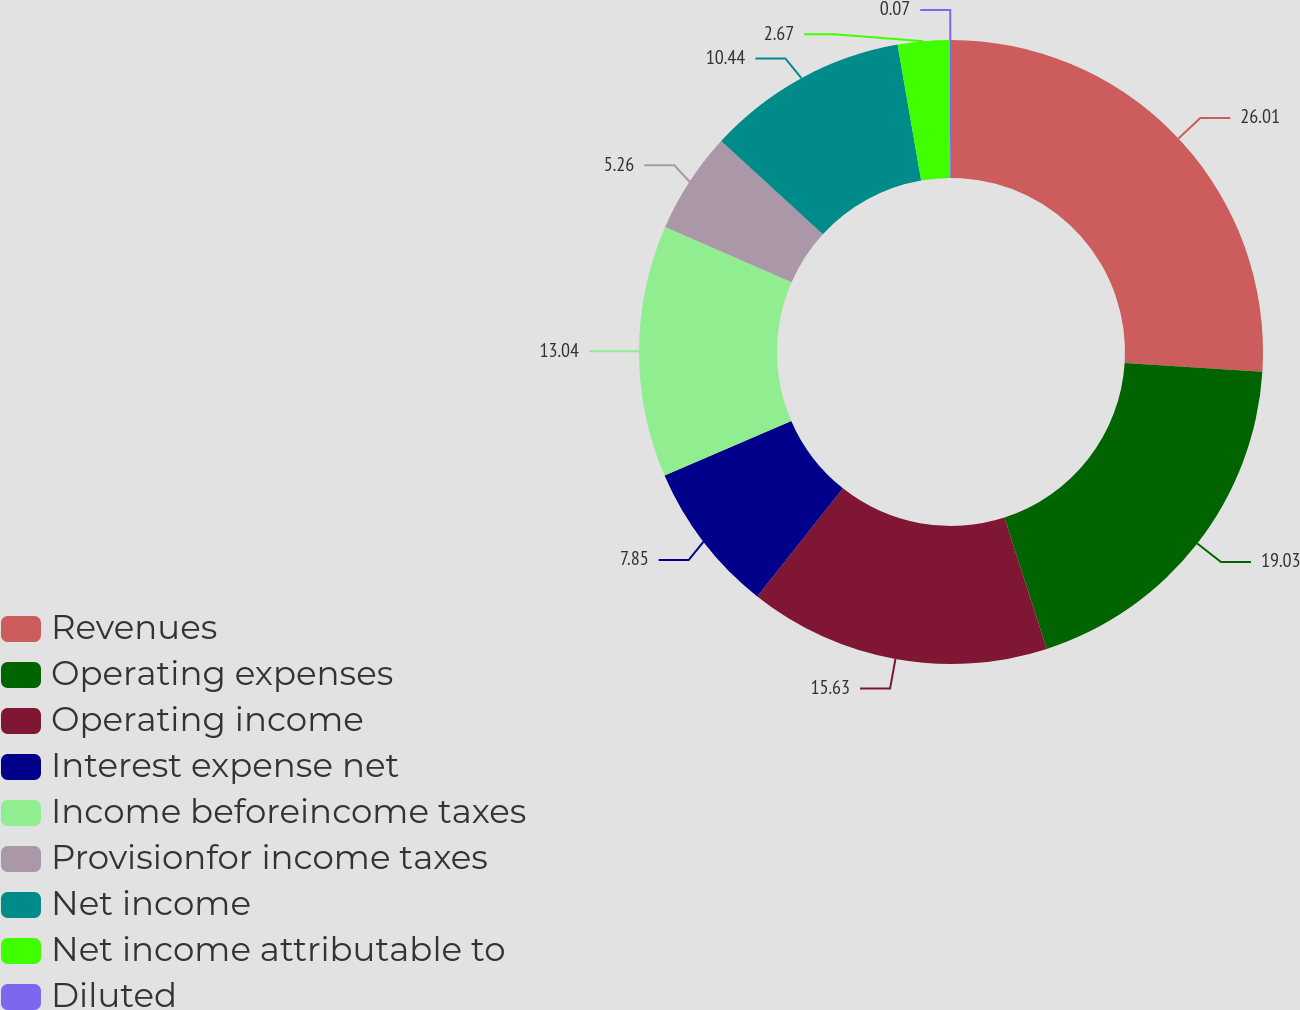Convert chart to OTSL. <chart><loc_0><loc_0><loc_500><loc_500><pie_chart><fcel>Revenues<fcel>Operating expenses<fcel>Operating income<fcel>Interest expense net<fcel>Income beforeincome taxes<fcel>Provisionfor income taxes<fcel>Net income<fcel>Net income attributable to<fcel>Diluted<nl><fcel>26.0%<fcel>19.03%<fcel>15.63%<fcel>7.85%<fcel>13.04%<fcel>5.26%<fcel>10.44%<fcel>2.67%<fcel>0.07%<nl></chart> 